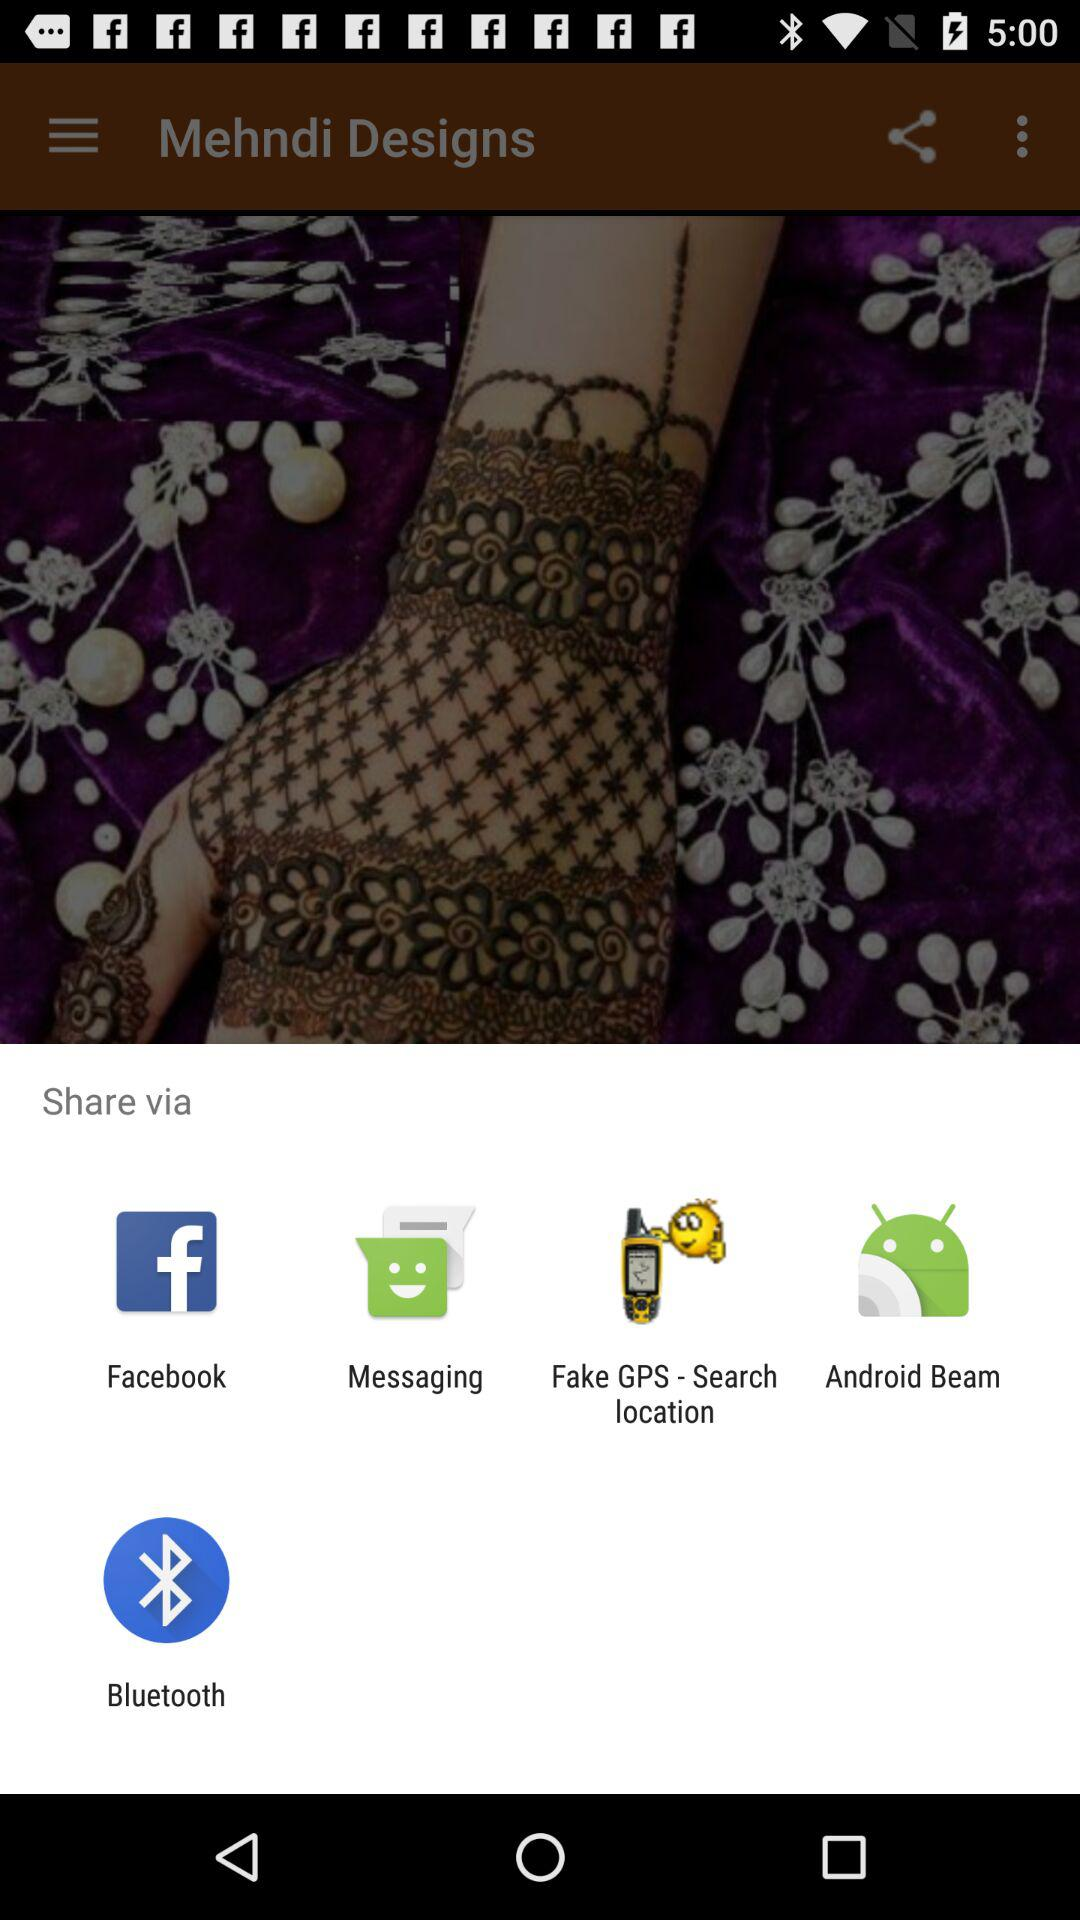Through which app can I share the content? You can share the content through "Facebook", "Messaging", "Fake GPS - Search location", "Android Beam" and "Bluetooth". 